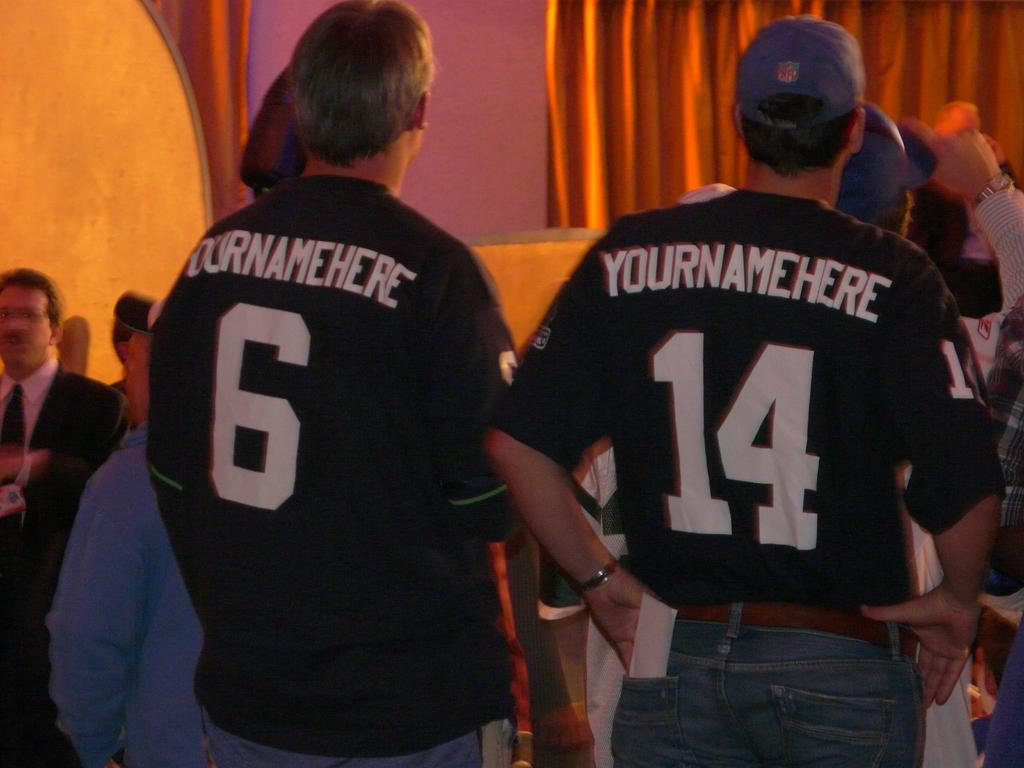Provide a one-sentence caption for the provided image. Two men wearing jerseys that say "yournamehere" on the back stand behind several other people. 